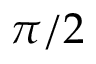<formula> <loc_0><loc_0><loc_500><loc_500>\pi / 2</formula> 